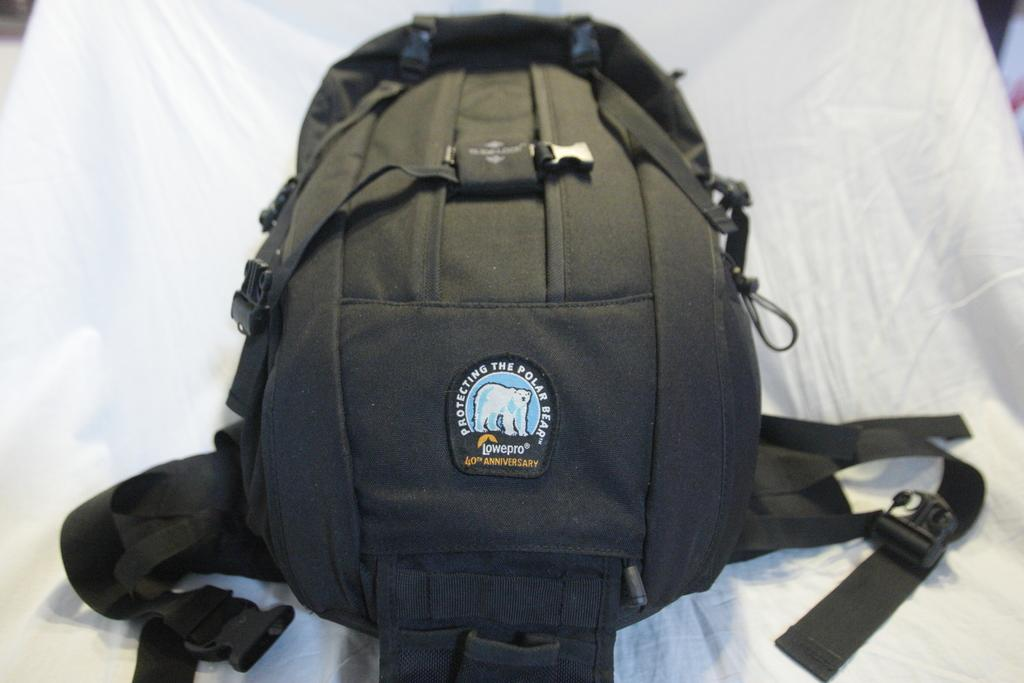What object can be seen in the image? There is a bag in the image. Is the bag taking a bath in the image? No, there is no indication of a bath or any water in the image, and the bag is not shown as being wet or submerged. 